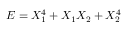Convert formula to latex. <formula><loc_0><loc_0><loc_500><loc_500>E = X _ { 1 } ^ { 4 } + X _ { 1 } X _ { 2 } + X _ { 2 } ^ { 4 }</formula> 